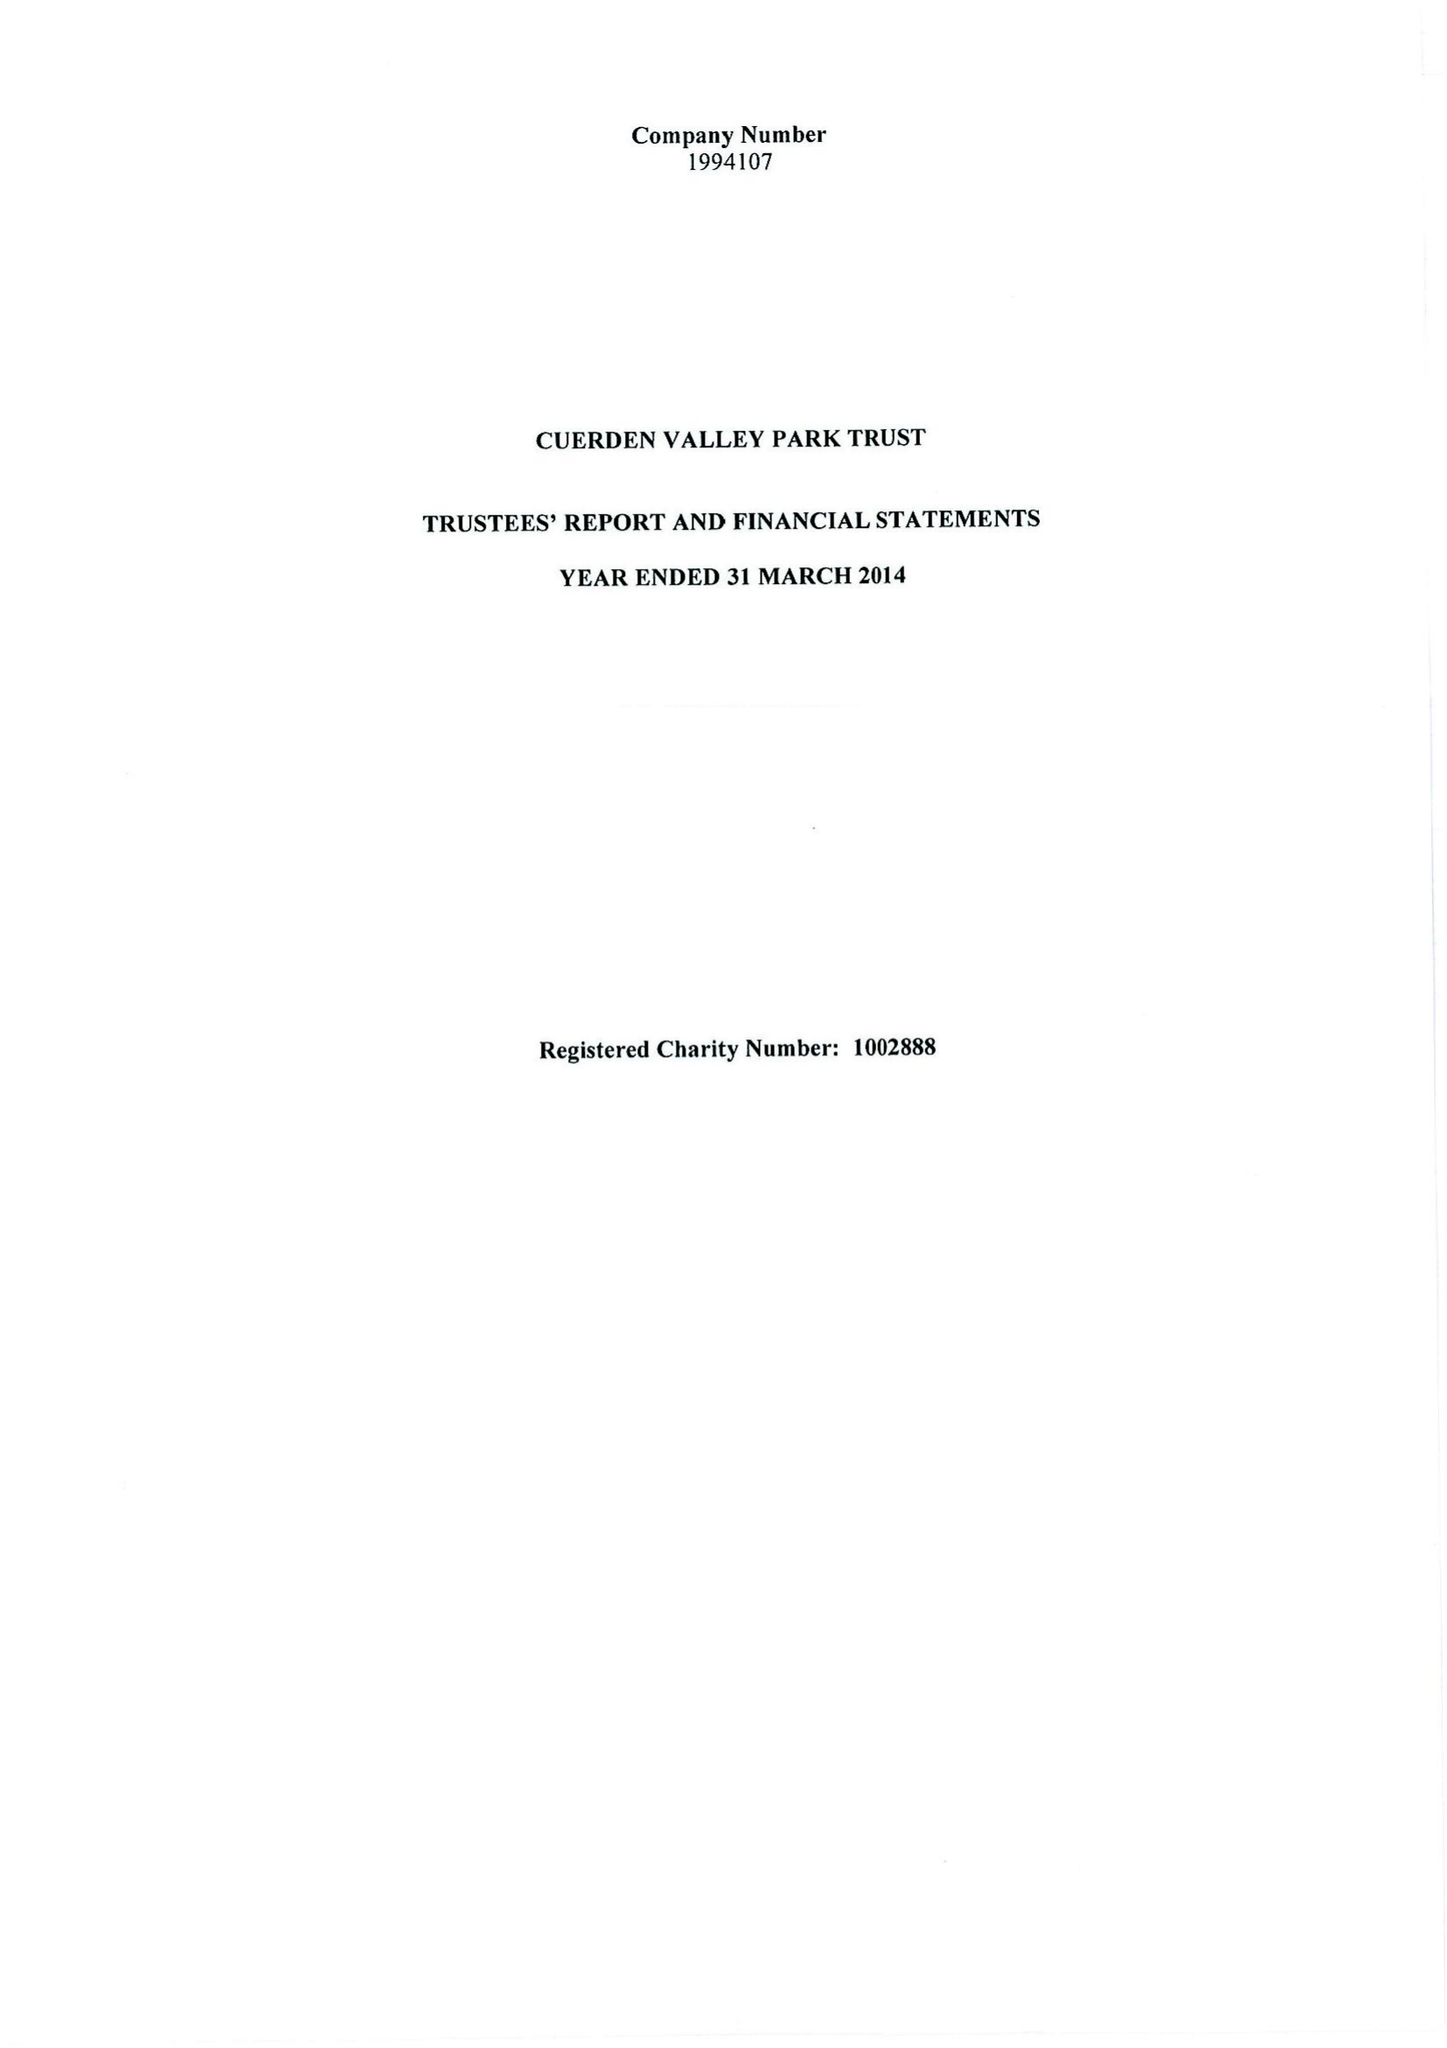What is the value for the address__street_line?
Answer the question using a single word or phrase. BERKELEY DRIVE 